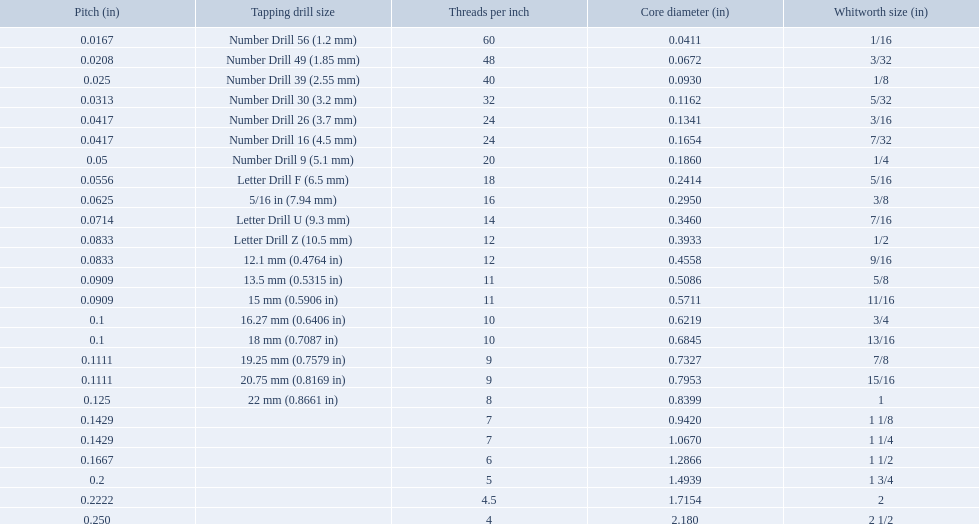What are all of the whitworth sizes? 1/16, 3/32, 1/8, 5/32, 3/16, 7/32, 1/4, 5/16, 3/8, 7/16, 1/2, 9/16, 5/8, 11/16, 3/4, 13/16, 7/8, 15/16, 1, 1 1/8, 1 1/4, 1 1/2, 1 3/4, 2, 2 1/2. How many threads per inch are in each size? 60, 48, 40, 32, 24, 24, 20, 18, 16, 14, 12, 12, 11, 11, 10, 10, 9, 9, 8, 7, 7, 6, 5, 4.5, 4. How many threads per inch are in the 3/16 size? 24. And which other size has the same number of threads? 7/32. What are the whitworth sizes? 1/16, 3/32, 1/8, 5/32, 3/16, 7/32, 1/4, 5/16, 3/8, 7/16, 1/2, 9/16, 5/8, 11/16, 3/4, 13/16, 7/8, 15/16, 1, 1 1/8, 1 1/4, 1 1/2, 1 3/4, 2, 2 1/2. And their threads per inch? 60, 48, 40, 32, 24, 24, 20, 18, 16, 14, 12, 12, 11, 11, 10, 10, 9, 9, 8, 7, 7, 6, 5, 4.5, 4. Now, which whitworth size has a thread-per-inch size of 5?? 1 3/4. 